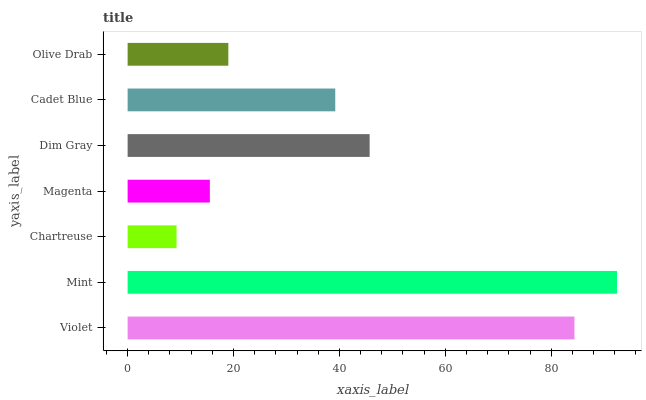Is Chartreuse the minimum?
Answer yes or no. Yes. Is Mint the maximum?
Answer yes or no. Yes. Is Mint the minimum?
Answer yes or no. No. Is Chartreuse the maximum?
Answer yes or no. No. Is Mint greater than Chartreuse?
Answer yes or no. Yes. Is Chartreuse less than Mint?
Answer yes or no. Yes. Is Chartreuse greater than Mint?
Answer yes or no. No. Is Mint less than Chartreuse?
Answer yes or no. No. Is Cadet Blue the high median?
Answer yes or no. Yes. Is Cadet Blue the low median?
Answer yes or no. Yes. Is Violet the high median?
Answer yes or no. No. Is Chartreuse the low median?
Answer yes or no. No. 